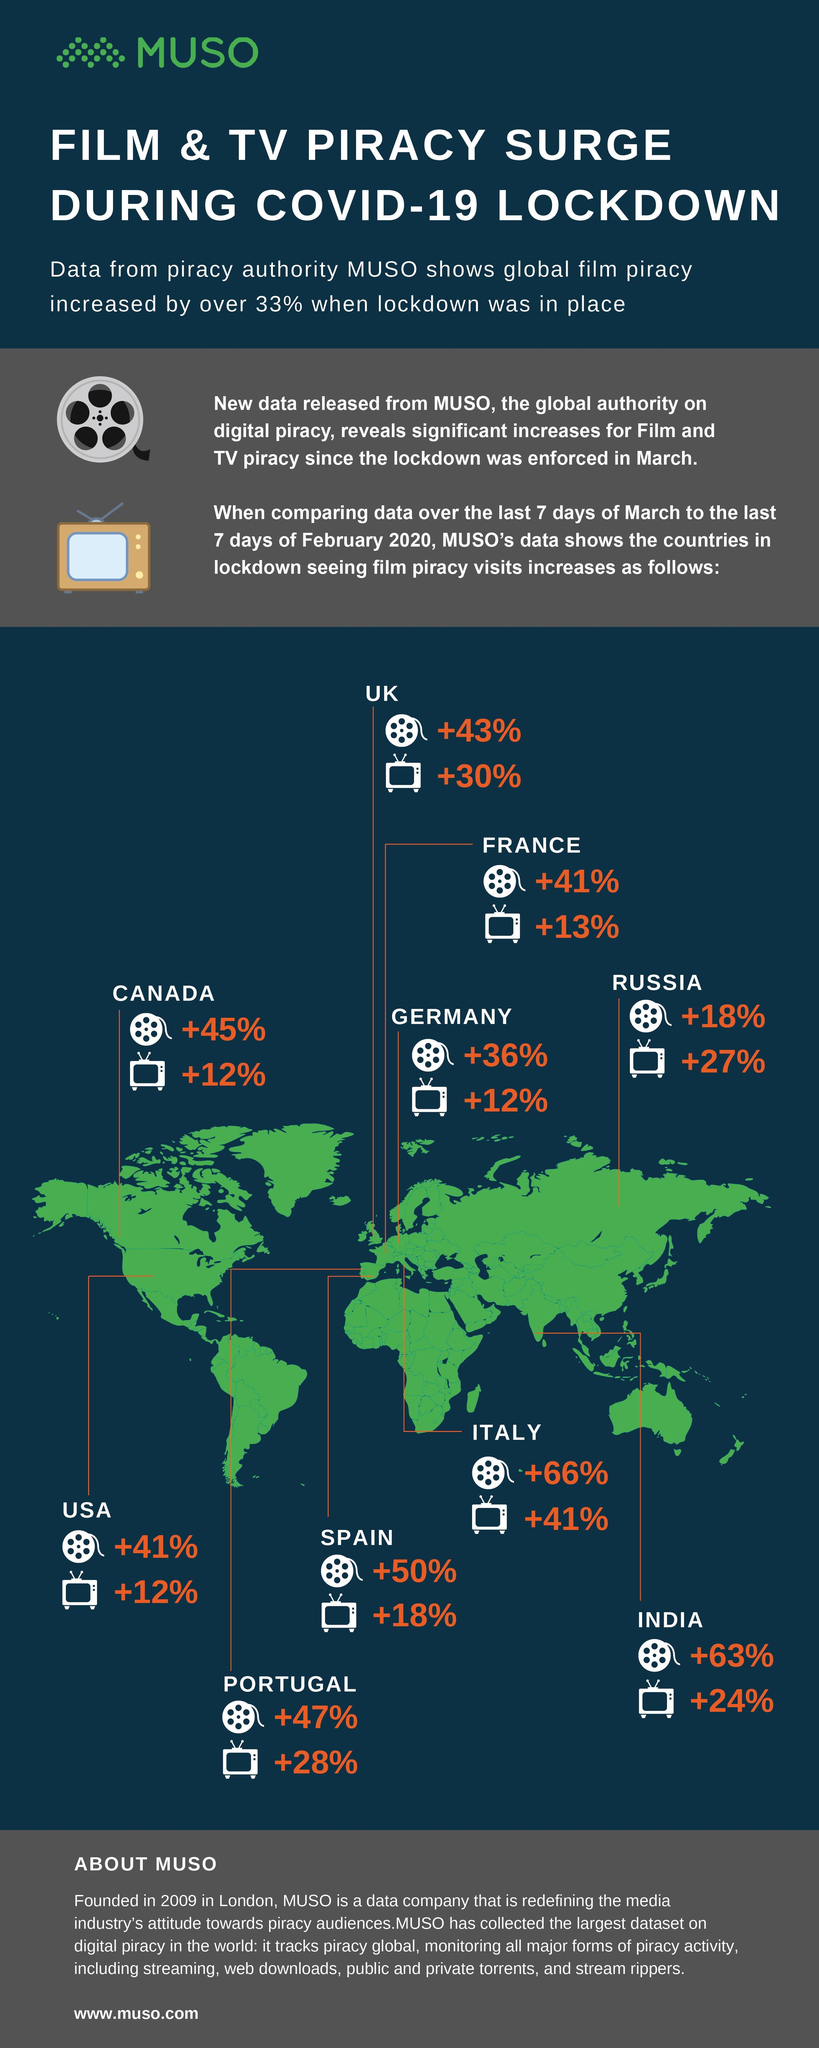How many television icons are there in the infographic?
Answer the question with a short phrase. 11 